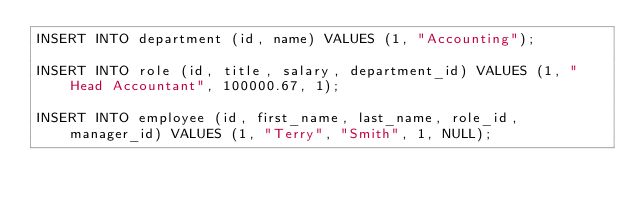Convert code to text. <code><loc_0><loc_0><loc_500><loc_500><_SQL_>INSERT INTO department (id, name) VALUES (1, "Accounting");

INSERT INTO role (id, title, salary, department_id) VALUES (1, "Head Accountant", 100000.67, 1);

INSERT INTO employee (id, first_name, last_name, role_id, manager_id) VALUES (1, "Terry", "Smith", 1, NULL);
</code> 